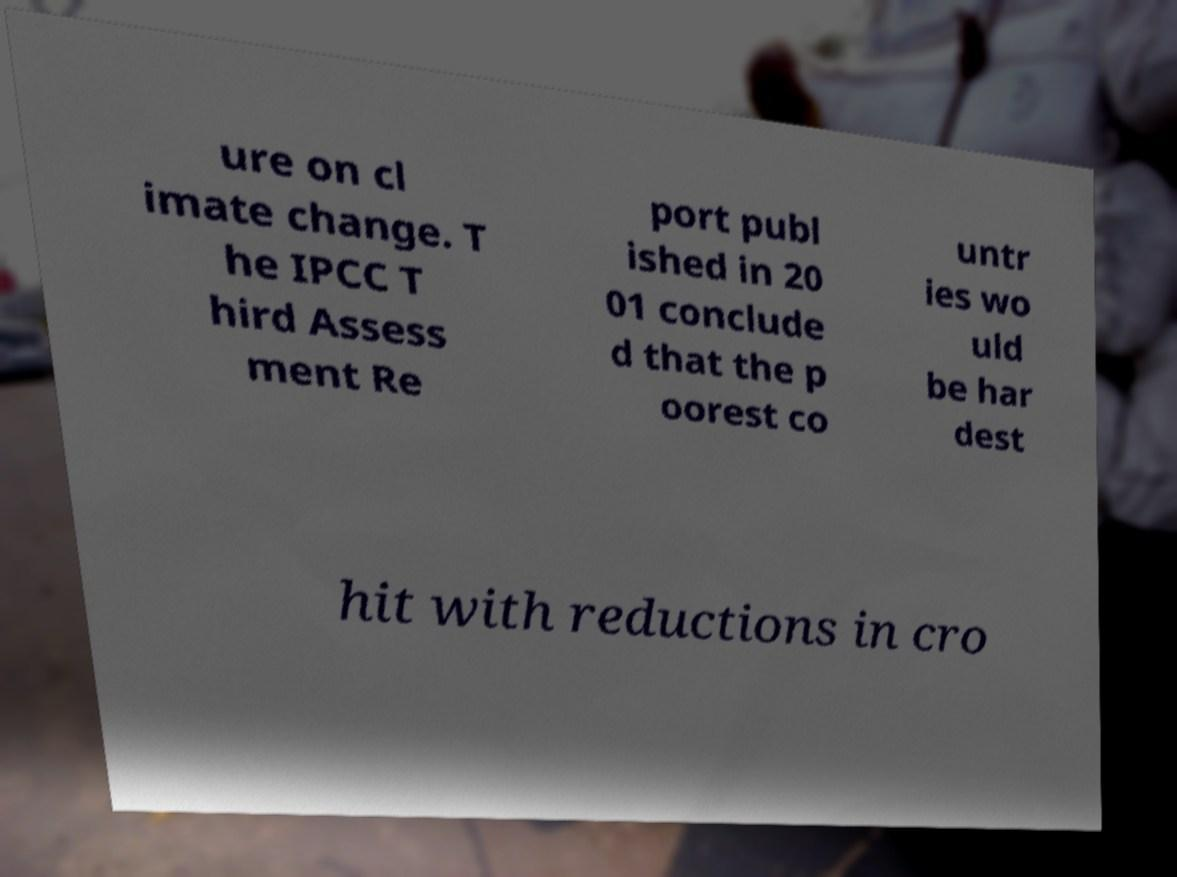For documentation purposes, I need the text within this image transcribed. Could you provide that? ure on cl imate change. T he IPCC T hird Assess ment Re port publ ished in 20 01 conclude d that the p oorest co untr ies wo uld be har dest hit with reductions in cro 